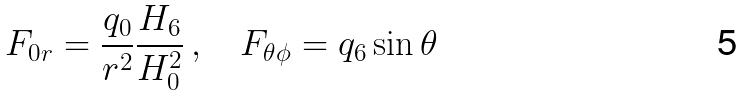Convert formula to latex. <formula><loc_0><loc_0><loc_500><loc_500>F _ { 0 r } = \frac { q _ { 0 } } { r ^ { 2 } } \frac { H _ { 6 } } { H _ { 0 } ^ { 2 } } \, , \quad F _ { \theta \phi } = q _ { 6 } \sin \theta</formula> 